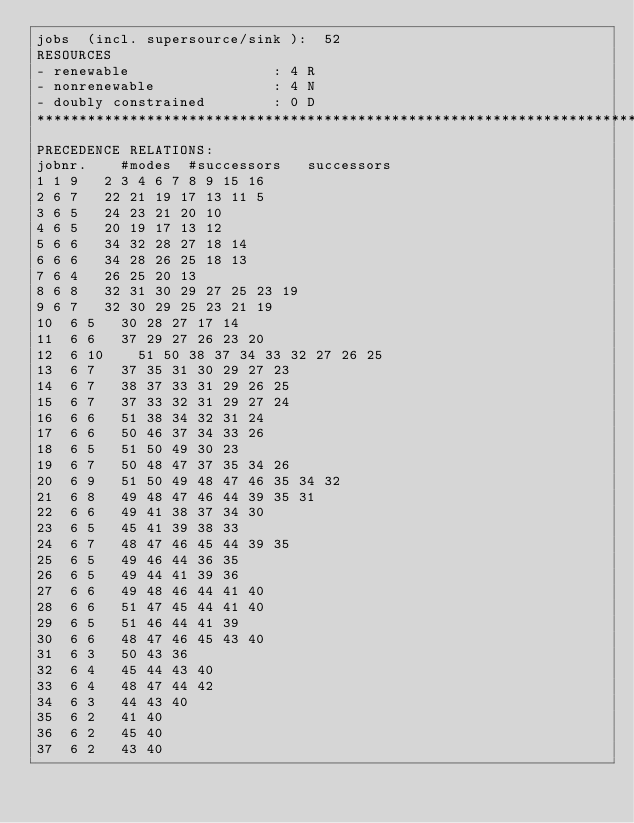Convert code to text. <code><loc_0><loc_0><loc_500><loc_500><_ObjectiveC_>jobs  (incl. supersource/sink ):	52
RESOURCES
- renewable                 : 4 R
- nonrenewable              : 4 N
- doubly constrained        : 0 D
************************************************************************
PRECEDENCE RELATIONS:
jobnr.    #modes  #successors   successors
1	1	9		2 3 4 6 7 8 9 15 16 
2	6	7		22 21 19 17 13 11 5 
3	6	5		24 23 21 20 10 
4	6	5		20 19 17 13 12 
5	6	6		34 32 28 27 18 14 
6	6	6		34 28 26 25 18 13 
7	6	4		26 25 20 13 
8	6	8		32 31 30 29 27 25 23 19 
9	6	7		32 30 29 25 23 21 19 
10	6	5		30 28 27 17 14 
11	6	6		37 29 27 26 23 20 
12	6	10		51 50 38 37 34 33 32 27 26 25 
13	6	7		37 35 31 30 29 27 23 
14	6	7		38 37 33 31 29 26 25 
15	6	7		37 33 32 31 29 27 24 
16	6	6		51 38 34 32 31 24 
17	6	6		50 46 37 34 33 26 
18	6	5		51 50 49 30 23 
19	6	7		50 48 47 37 35 34 26 
20	6	9		51 50 49 48 47 46 35 34 32 
21	6	8		49 48 47 46 44 39 35 31 
22	6	6		49 41 38 37 34 30 
23	6	5		45 41 39 38 33 
24	6	7		48 47 46 45 44 39 35 
25	6	5		49 46 44 36 35 
26	6	5		49 44 41 39 36 
27	6	6		49 48 46 44 41 40 
28	6	6		51 47 45 44 41 40 
29	6	5		51 46 44 41 39 
30	6	6		48 47 46 45 43 40 
31	6	3		50 43 36 
32	6	4		45 44 43 40 
33	6	4		48 47 44 42 
34	6	3		44 43 40 
35	6	2		41 40 
36	6	2		45 40 
37	6	2		43 40 </code> 